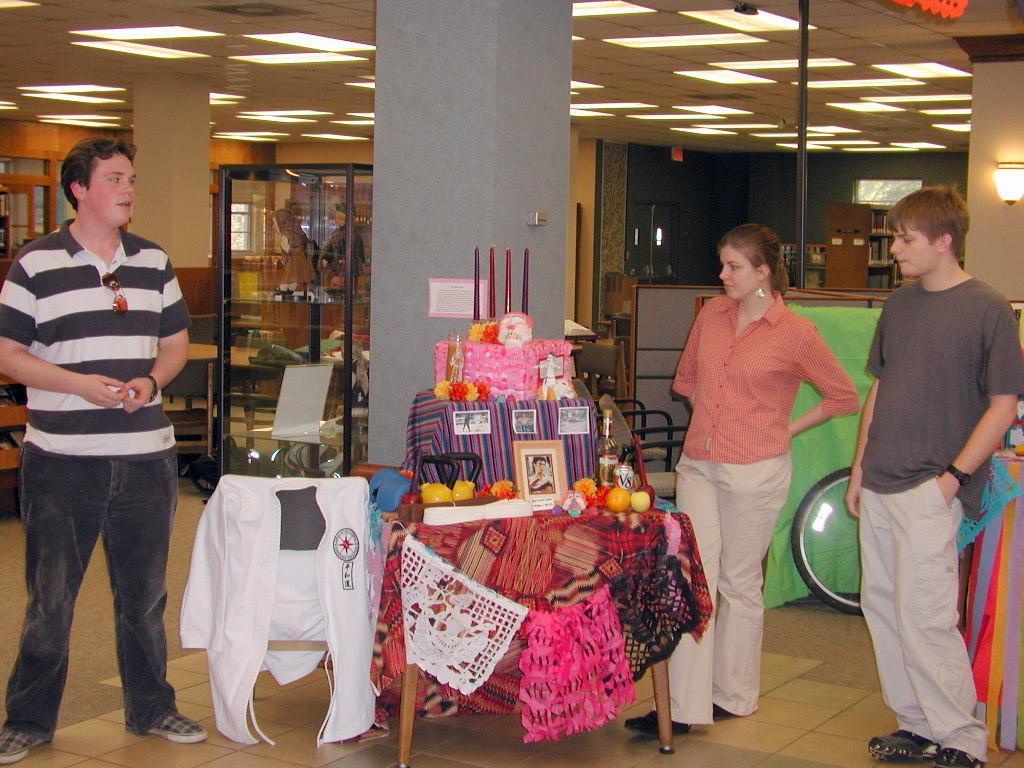Describe this image in one or two sentences. In the image we can see two men and a woman standing, wearing clothes, shoes and the woman is wearing earrings. Here we can see clothes and frames. Here we can see floor, wheel, pillar, pole and lights. 